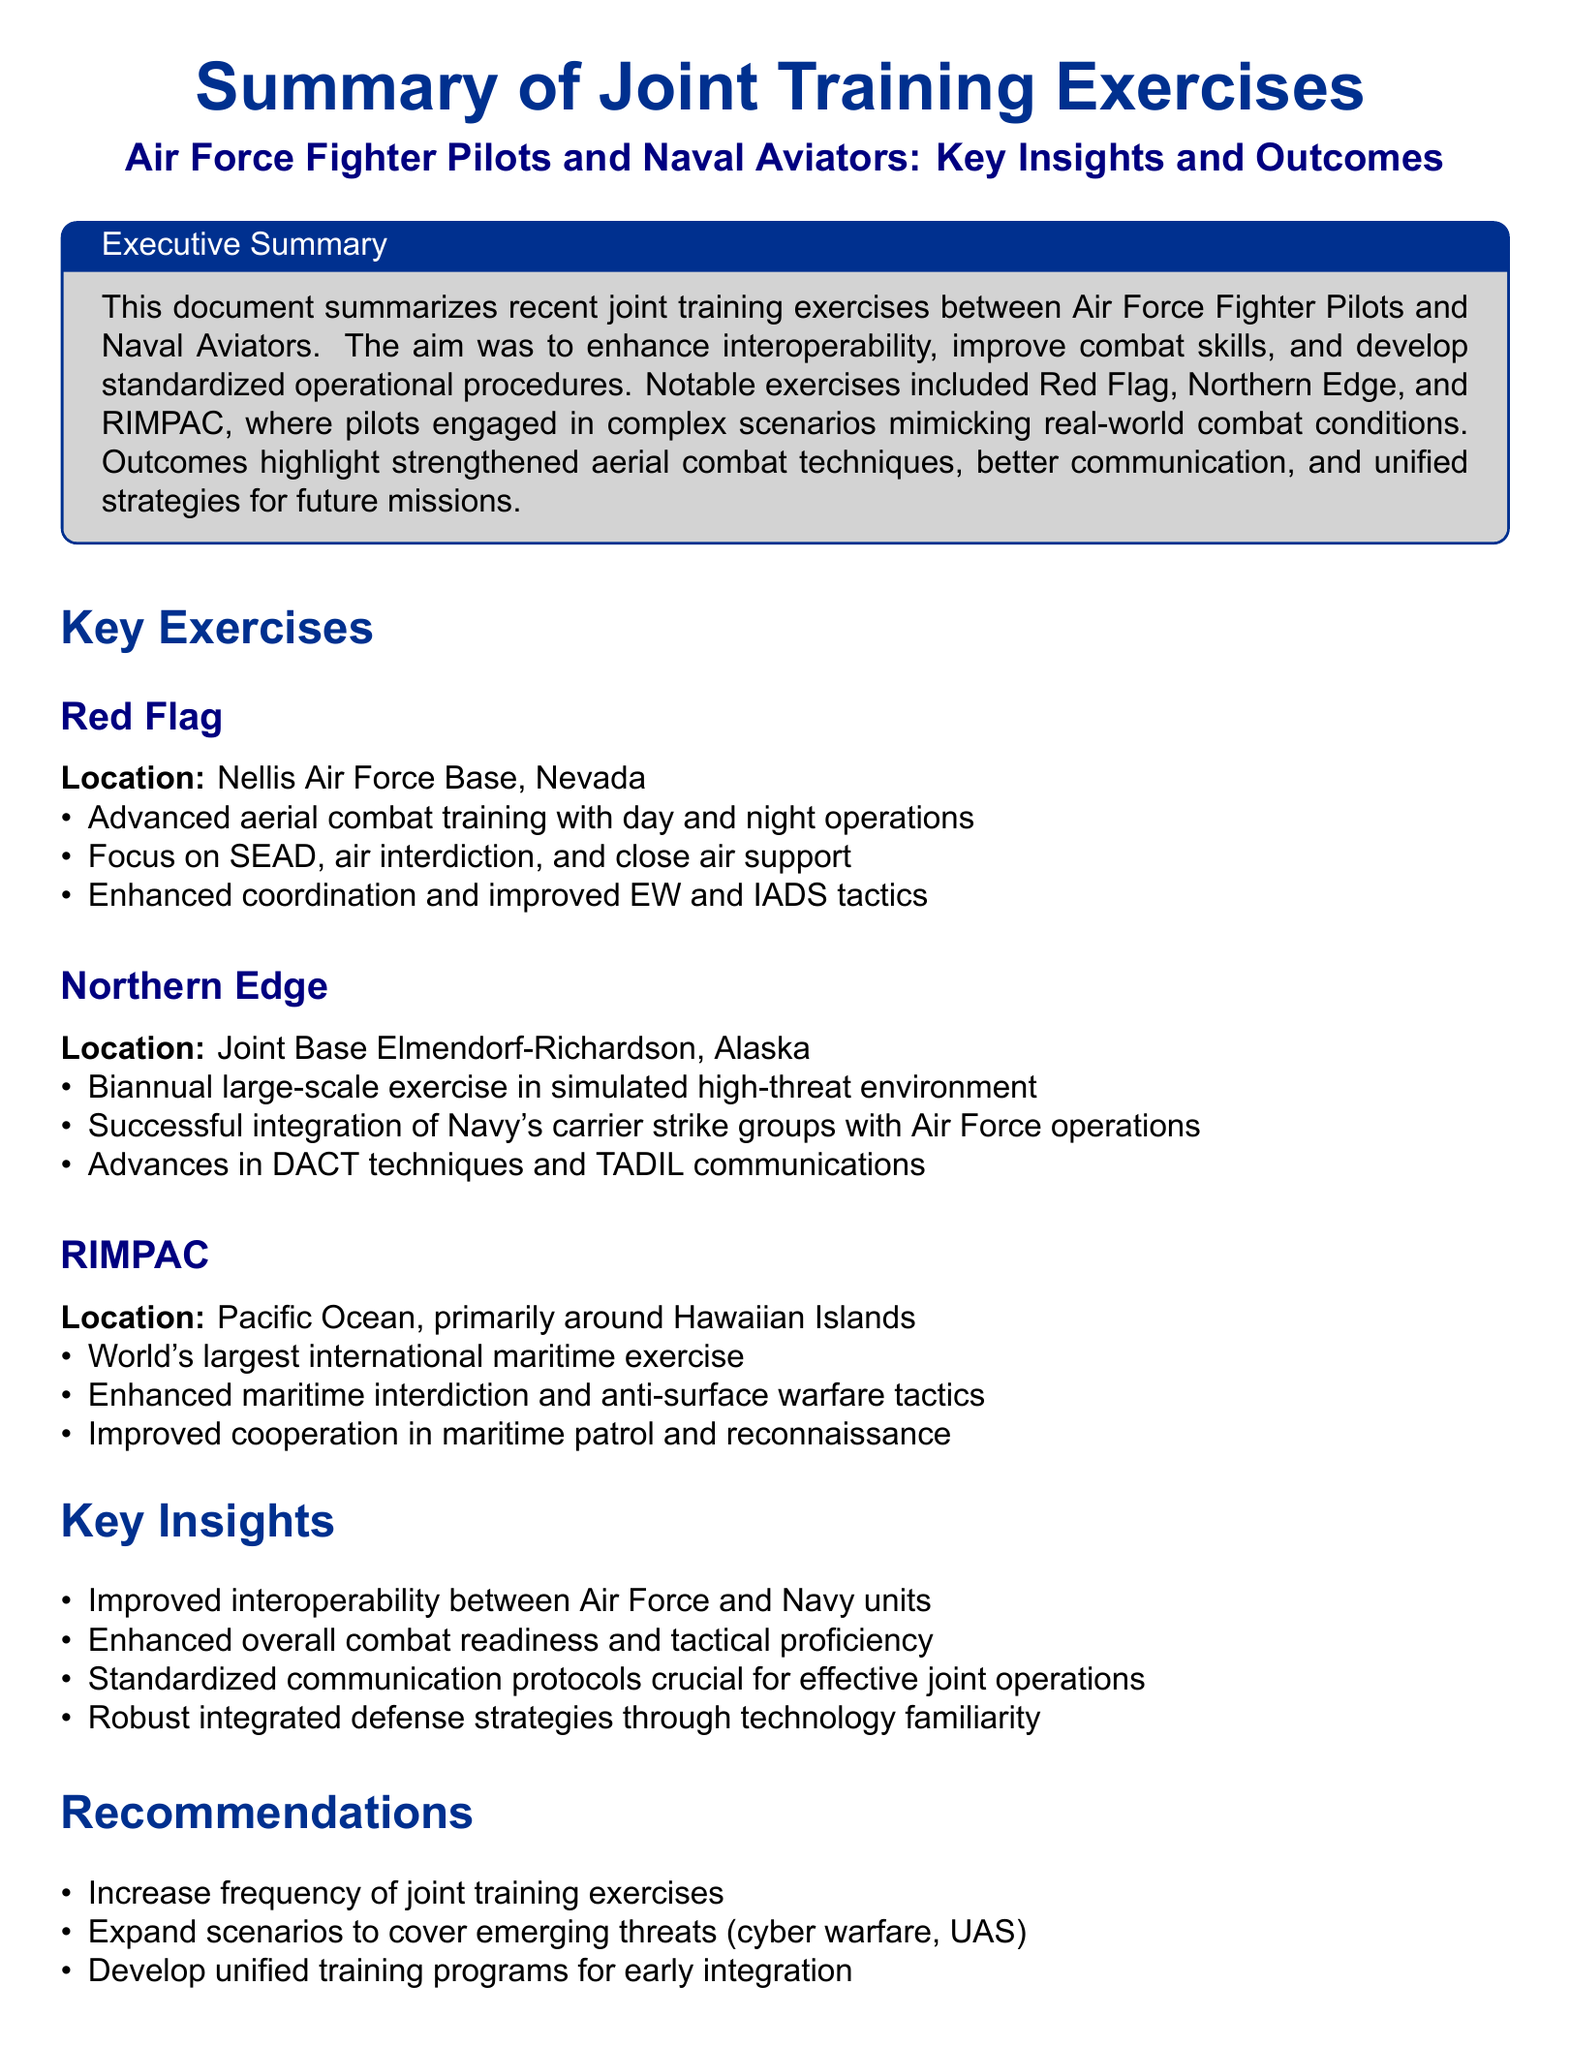What is the purpose of the joint training exercises? The purpose is to enhance interoperability, improve combat skills, and develop standardized operational procedures.
Answer: Enhance interoperability, improve combat skills, and develop standardized operational procedures What is the location of Red Flag exercise? Red Flag exercise took place at Nellis Air Force Base, Nevada.
Answer: Nellis Air Force Base, Nevada What type of exercise is RIMPAC? RIMPAC is the world's largest international maritime exercise.
Answer: World's largest international maritime exercise What significant improvement was noted in the Key Insights? Improved interoperability between Air Force and Navy units was a significant improvement.
Answer: Improved interoperability between Air Force and Navy units How often is the Northern Edge exercise held? The Northern Edge exercise is conducted biannually.
Answer: Biannually What is recommended for training scenarios? It is recommended to expand scenarios to cover emerging threats (cyber warfare, UAS).
Answer: Expand scenarios to cover emerging threats (cyber warfare, UAS) What was enhanced during the Northern Edge exercise? Successful integration of Navy's carrier strike groups with Air Force operations was enhanced.
Answer: Successful integration of Navy's carrier strike groups with Air Force operations What does DACT stand for? DACT stands for Dissimilar Air Combat Training.
Answer: Dissimilar Air Combat Training 